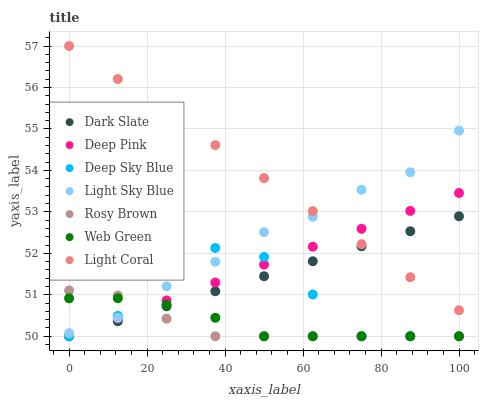Does Rosy Brown have the minimum area under the curve?
Answer yes or no. Yes. Does Light Coral have the maximum area under the curve?
Answer yes or no. Yes. Does Web Green have the minimum area under the curve?
Answer yes or no. No. Does Web Green have the maximum area under the curve?
Answer yes or no. No. Is Light Coral the smoothest?
Answer yes or no. Yes. Is Deep Sky Blue the roughest?
Answer yes or no. Yes. Is Rosy Brown the smoothest?
Answer yes or no. No. Is Rosy Brown the roughest?
Answer yes or no. No. Does Deep Pink have the lowest value?
Answer yes or no. Yes. Does Light Coral have the lowest value?
Answer yes or no. No. Does Light Coral have the highest value?
Answer yes or no. Yes. Does Rosy Brown have the highest value?
Answer yes or no. No. Is Rosy Brown less than Light Coral?
Answer yes or no. Yes. Is Light Sky Blue greater than Dark Slate?
Answer yes or no. Yes. Does Web Green intersect Light Sky Blue?
Answer yes or no. Yes. Is Web Green less than Light Sky Blue?
Answer yes or no. No. Is Web Green greater than Light Sky Blue?
Answer yes or no. No. Does Rosy Brown intersect Light Coral?
Answer yes or no. No. 